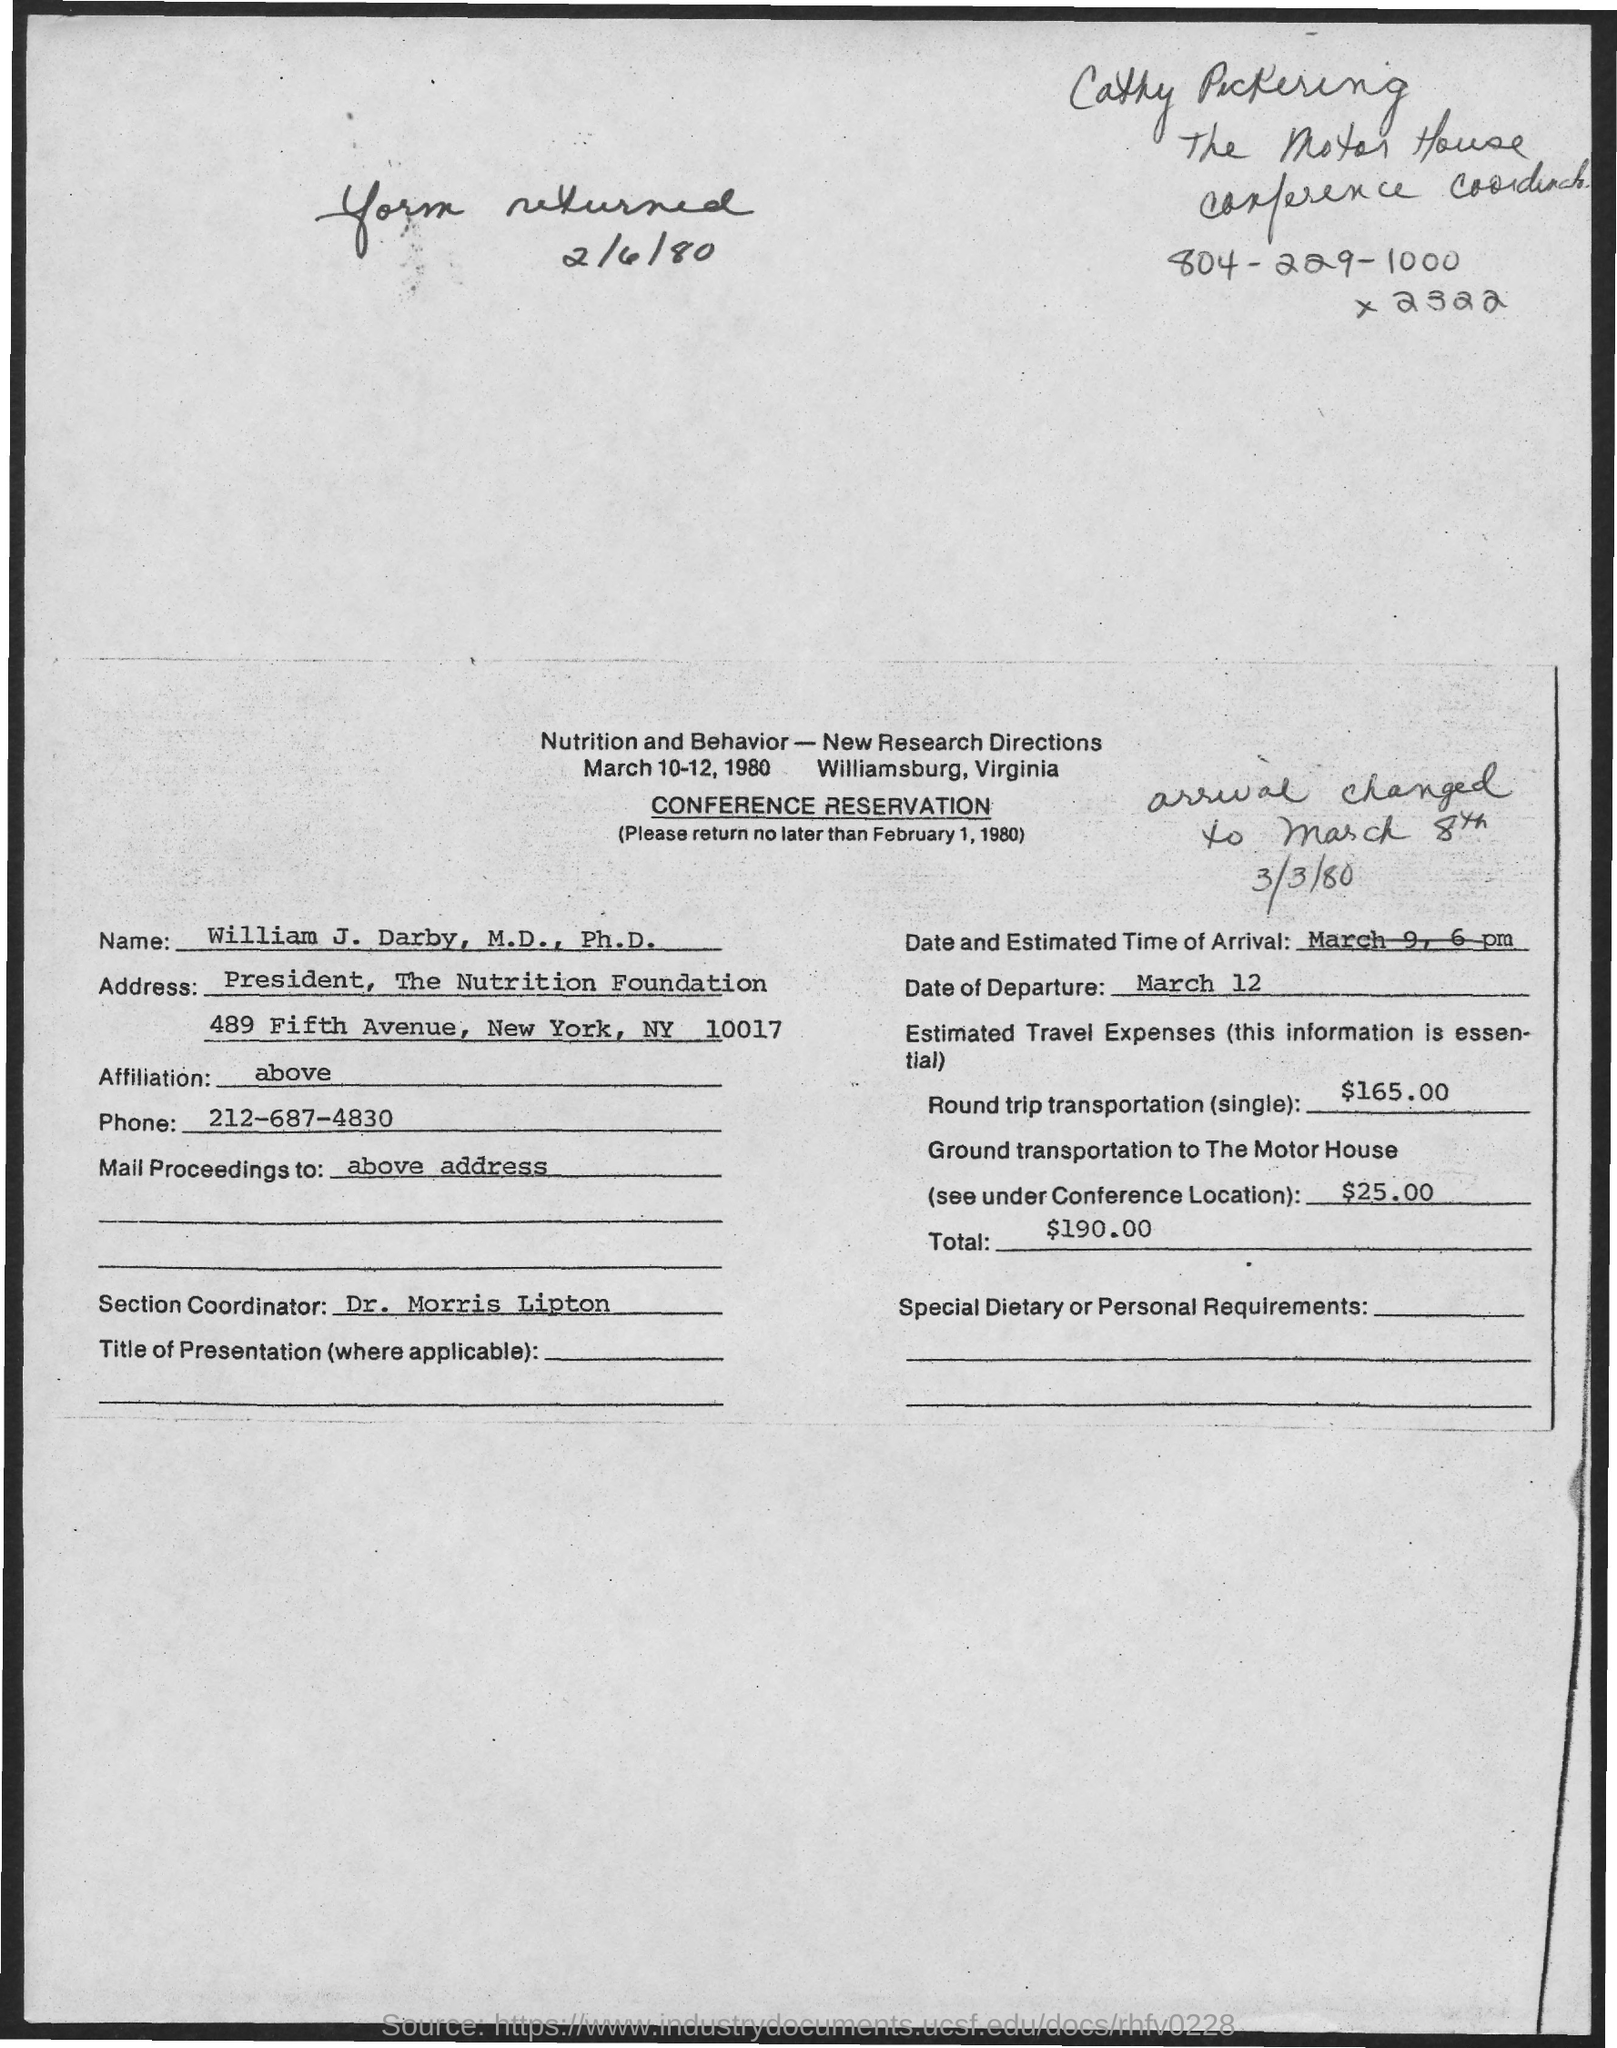Outline some significant characteristics in this image. The form must be returned by no later than February 1, 1980. The name is William J. Darby. The date of departure is March 12. The estimated cost of ground transportation to The Motor House is $25.00. The phone number `212-687-4830` is a telephone number. 